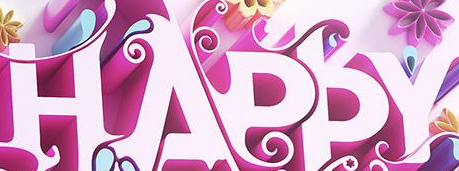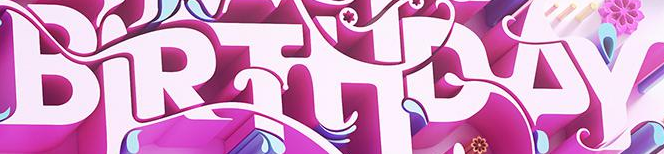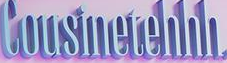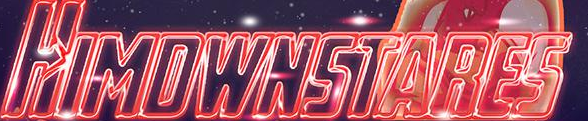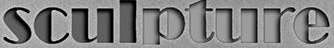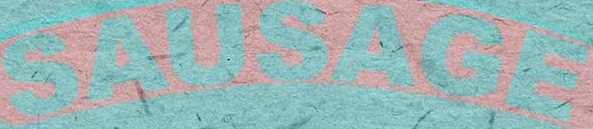Identify the words shown in these images in order, separated by a semicolon. HAPPY; BIRTHDAY; Cousinetehhh; HIMDWNSTARES; sculpture; SAUSAGE 